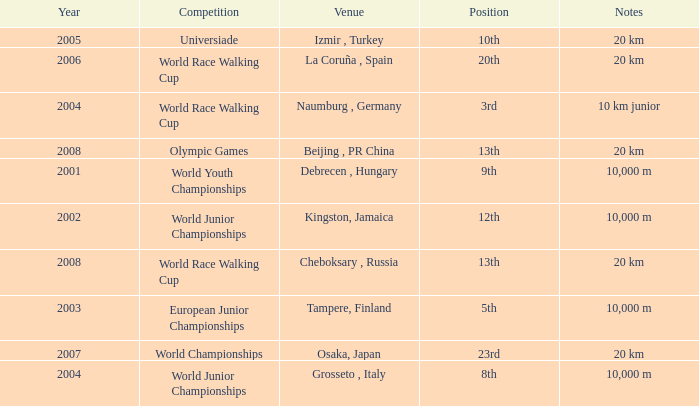In which year did he compete in the Universiade? 2005.0. I'm looking to parse the entire table for insights. Could you assist me with that? {'header': ['Year', 'Competition', 'Venue', 'Position', 'Notes'], 'rows': [['2005', 'Universiade', 'Izmir , Turkey', '10th', '20 km'], ['2006', 'World Race Walking Cup', 'La Coruña , Spain', '20th', '20 km'], ['2004', 'World Race Walking Cup', 'Naumburg , Germany', '3rd', '10 km junior'], ['2008', 'Olympic Games', 'Beijing , PR China', '13th', '20 km'], ['2001', 'World Youth Championships', 'Debrecen , Hungary', '9th', '10,000 m'], ['2002', 'World Junior Championships', 'Kingston, Jamaica', '12th', '10,000 m'], ['2008', 'World Race Walking Cup', 'Cheboksary , Russia', '13th', '20 km'], ['2003', 'European Junior Championships', 'Tampere, Finland', '5th', '10,000 m'], ['2007', 'World Championships', 'Osaka, Japan', '23rd', '20 km'], ['2004', 'World Junior Championships', 'Grosseto , Italy', '8th', '10,000 m']]} 